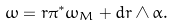<formula> <loc_0><loc_0><loc_500><loc_500>\omega = r \pi ^ { * } \omega _ { M } + d r \wedge \alpha .</formula> 